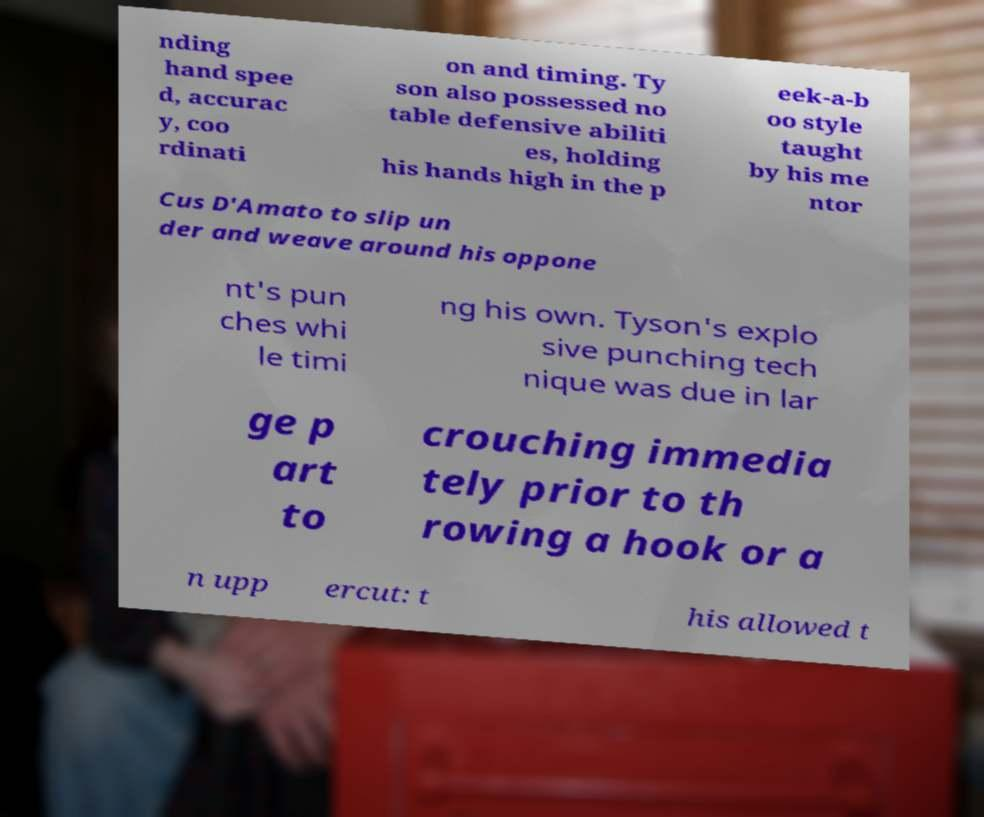Please identify and transcribe the text found in this image. nding hand spee d, accurac y, coo rdinati on and timing. Ty son also possessed no table defensive abiliti es, holding his hands high in the p eek-a-b oo style taught by his me ntor Cus D'Amato to slip un der and weave around his oppone nt's pun ches whi le timi ng his own. Tyson's explo sive punching tech nique was due in lar ge p art to crouching immedia tely prior to th rowing a hook or a n upp ercut: t his allowed t 